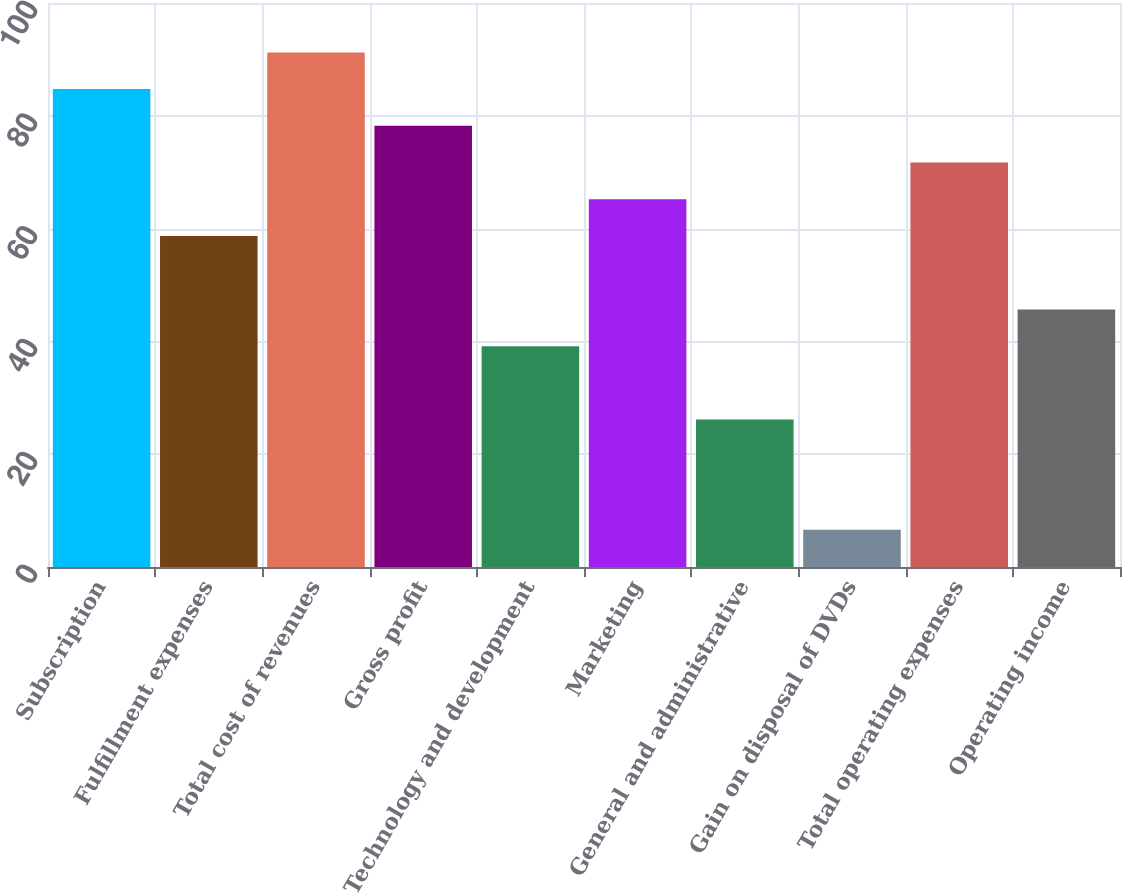Convert chart. <chart><loc_0><loc_0><loc_500><loc_500><bar_chart><fcel>Subscription<fcel>Fulfillment expenses<fcel>Total cost of revenues<fcel>Gross profit<fcel>Technology and development<fcel>Marketing<fcel>General and administrative<fcel>Gain on disposal of DVDs<fcel>Total operating expenses<fcel>Operating income<nl><fcel>84.73<fcel>58.69<fcel>91.24<fcel>78.22<fcel>39.16<fcel>65.2<fcel>26.14<fcel>6.61<fcel>71.71<fcel>45.67<nl></chart> 